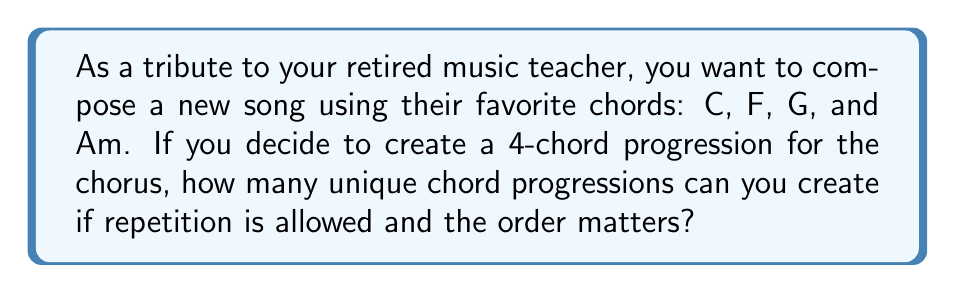Can you answer this question? Let's approach this step-by-step:

1) We have 4 chords to choose from: C, F, G, and Am.

2) We need to create a 4-chord progression.

3) Repetition is allowed, which means we can use the same chord multiple times in our progression.

4) The order matters, meaning "C-F-G-Am" is considered different from "Am-G-F-C".

5) This scenario is a perfect example of a permutation with repetition.

6) The formula for permutations with repetition is:

   $$n^r$$

   Where:
   $n$ = number of items to choose from
   $r$ = number of positions to fill

7) In our case:
   $n = 4$ (4 chords to choose from)
   $r = 4$ (4 positions in the progression)

8) Plugging these values into our formula:

   $$4^4 = 256$$

Therefore, you can create 256 unique 4-chord progressions using C, F, G, and Am.
Answer: 256 